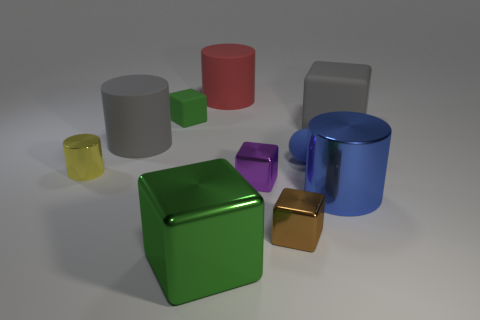What material is the cylinder that is the same color as the small ball?
Offer a terse response. Metal. There is a tiny purple object that is the same shape as the tiny green rubber thing; what is it made of?
Provide a succinct answer. Metal. Do the object on the left side of the gray matte cylinder and the red object have the same shape?
Provide a succinct answer. Yes. Is there any other thing that has the same color as the rubber ball?
Your response must be concise. Yes. The metallic object that is the same color as the tiny rubber sphere is what shape?
Keep it short and to the point. Cylinder. There is a metal cylinder that is on the right side of the small cylinder; does it have the same color as the matte ball?
Your answer should be very brief. Yes. What is the material of the thing that is both to the left of the purple metallic object and in front of the tiny yellow cylinder?
Ensure brevity in your answer.  Metal. How many other tiny rubber objects have the same shape as the purple object?
Your response must be concise. 1. How many big objects are both behind the green shiny block and in front of the brown thing?
Your answer should be very brief. 0. What is the color of the small rubber ball?
Offer a terse response. Blue. 